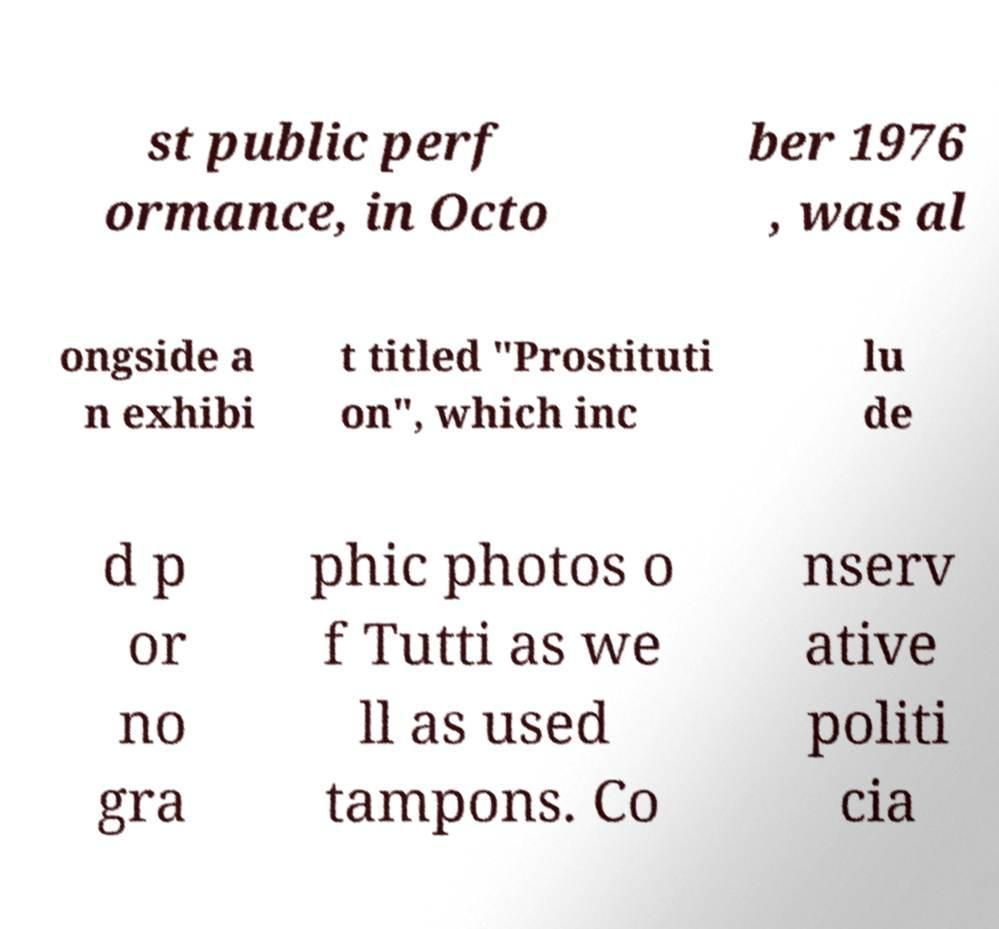There's text embedded in this image that I need extracted. Can you transcribe it verbatim? st public perf ormance, in Octo ber 1976 , was al ongside a n exhibi t titled "Prostituti on", which inc lu de d p or no gra phic photos o f Tutti as we ll as used tampons. Co nserv ative politi cia 